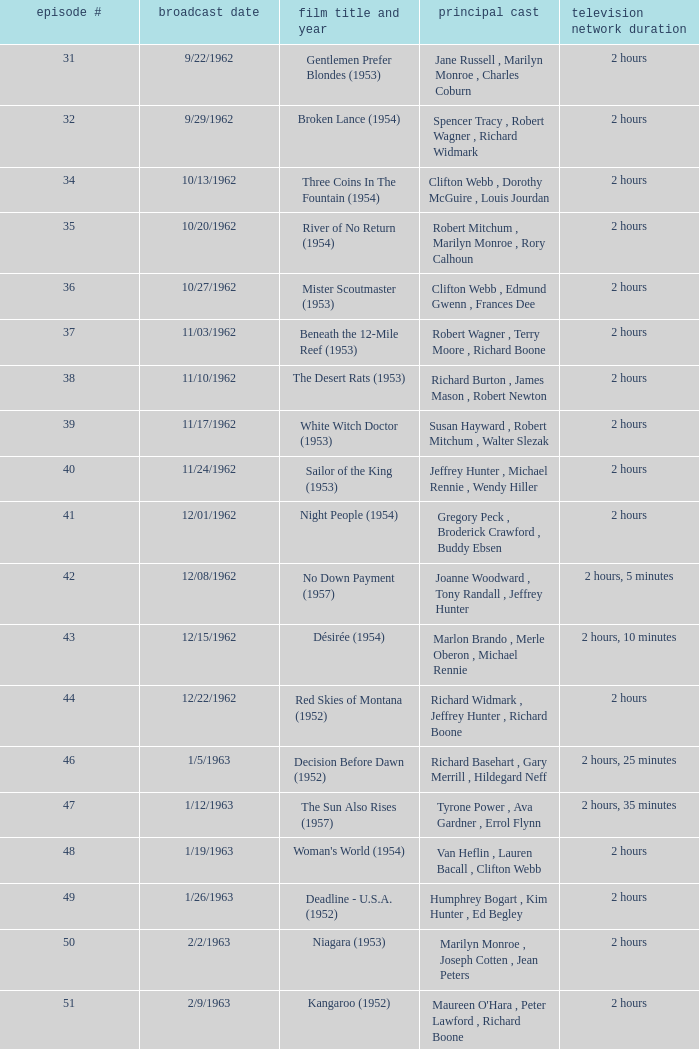How many runtimes does episode 53 have? 1.0. 